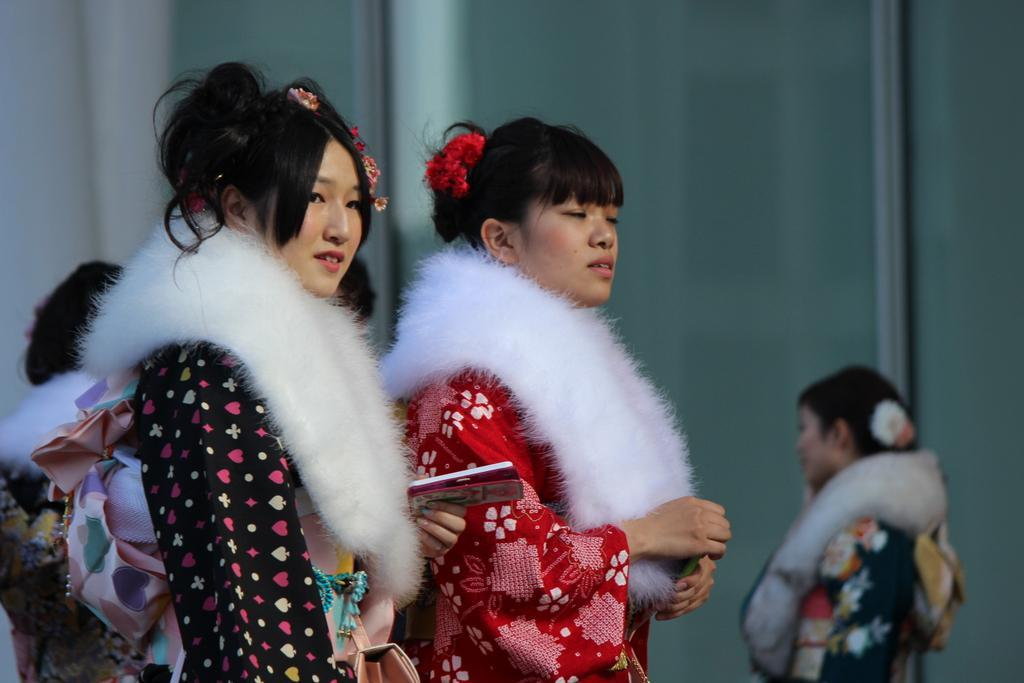What can be seen in the image? There are women standing in the image. What are the women wearing? The women are wearing traditional dresses. What is visible in the background of the image? There is a wall in the background of the image. What type of rod can be seen in the hands of the women in the image? There is no rod present in the hands of the women in the image. How many crows are perched on the wall in the background of the image? There are no crows present in the image, and therefore no crows can be seen on the wall. 